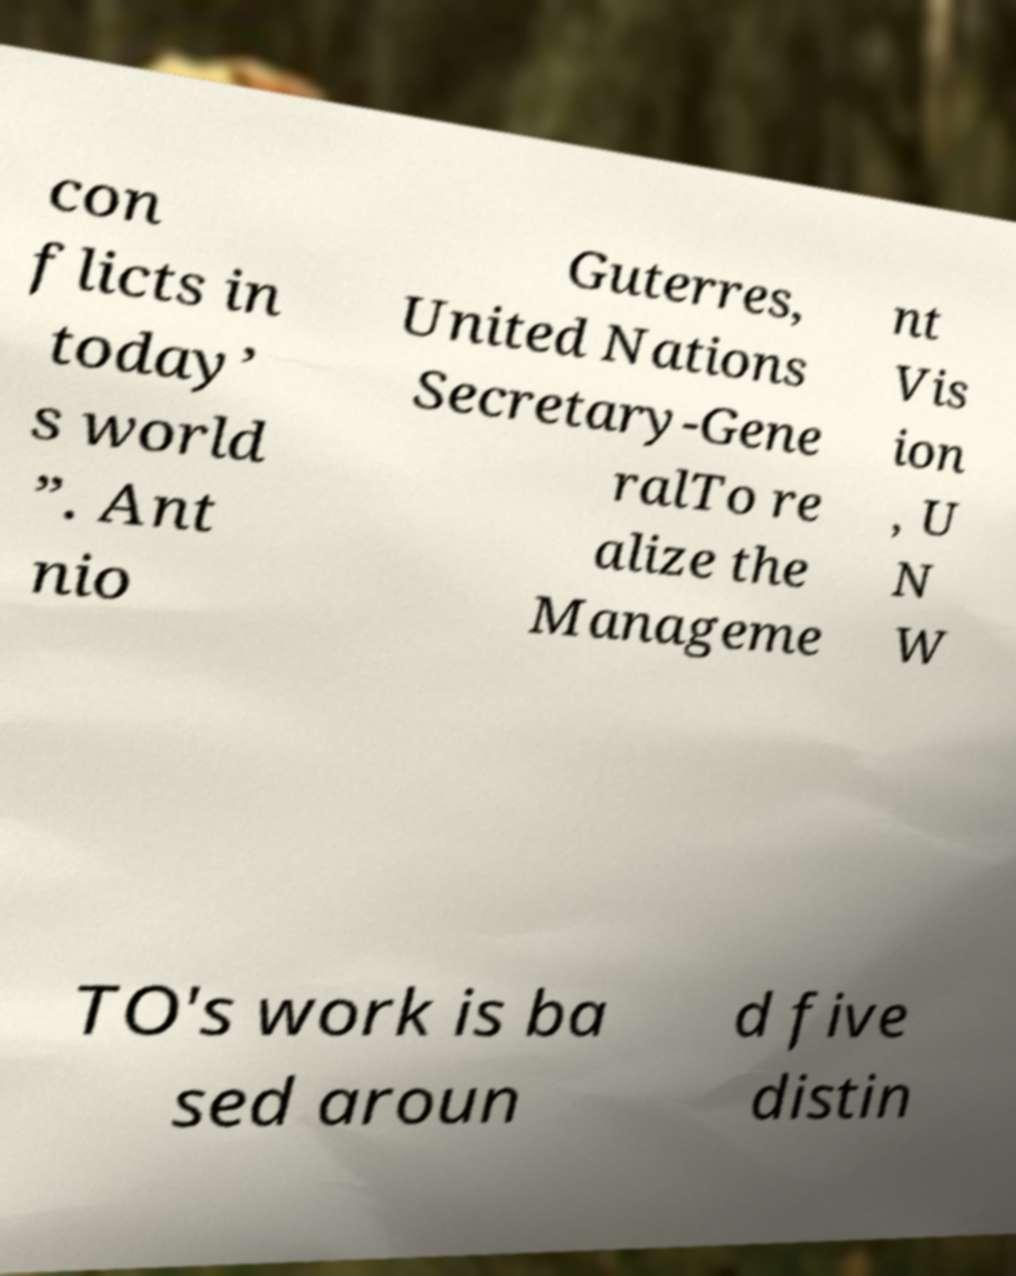Could you assist in decoding the text presented in this image and type it out clearly? con flicts in today’ s world ”. Ant nio Guterres, United Nations Secretary-Gene ralTo re alize the Manageme nt Vis ion , U N W TO's work is ba sed aroun d five distin 